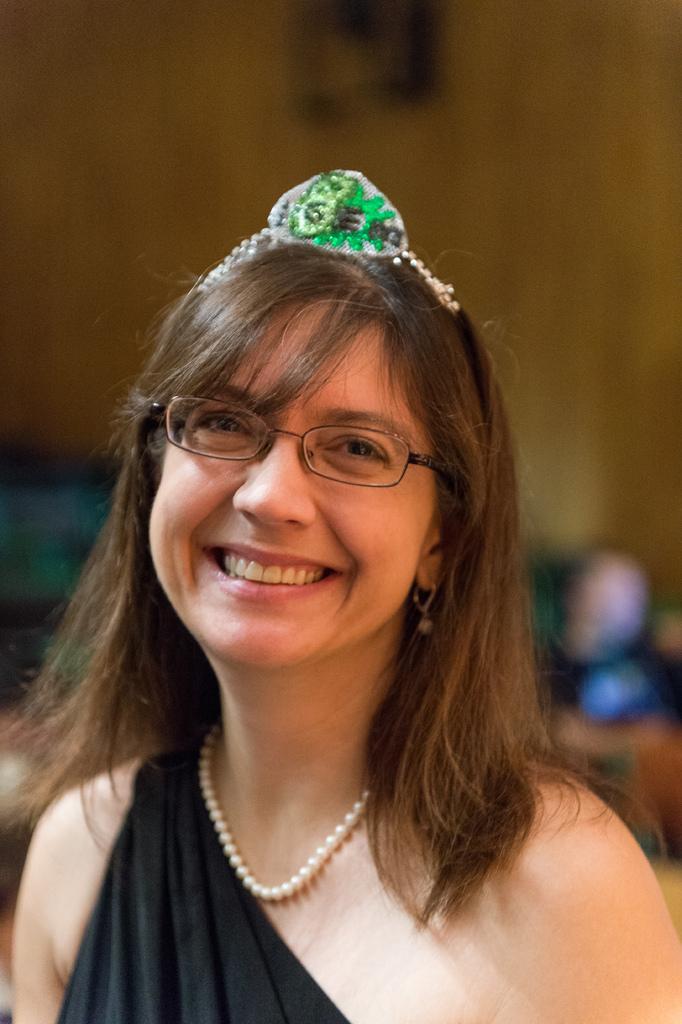Could you give a brief overview of what you see in this image? In this image I can see a woman is wearing black color dress, smiling and giving pose for the picture. I can see a crown on her head. In the background there is a wall. 